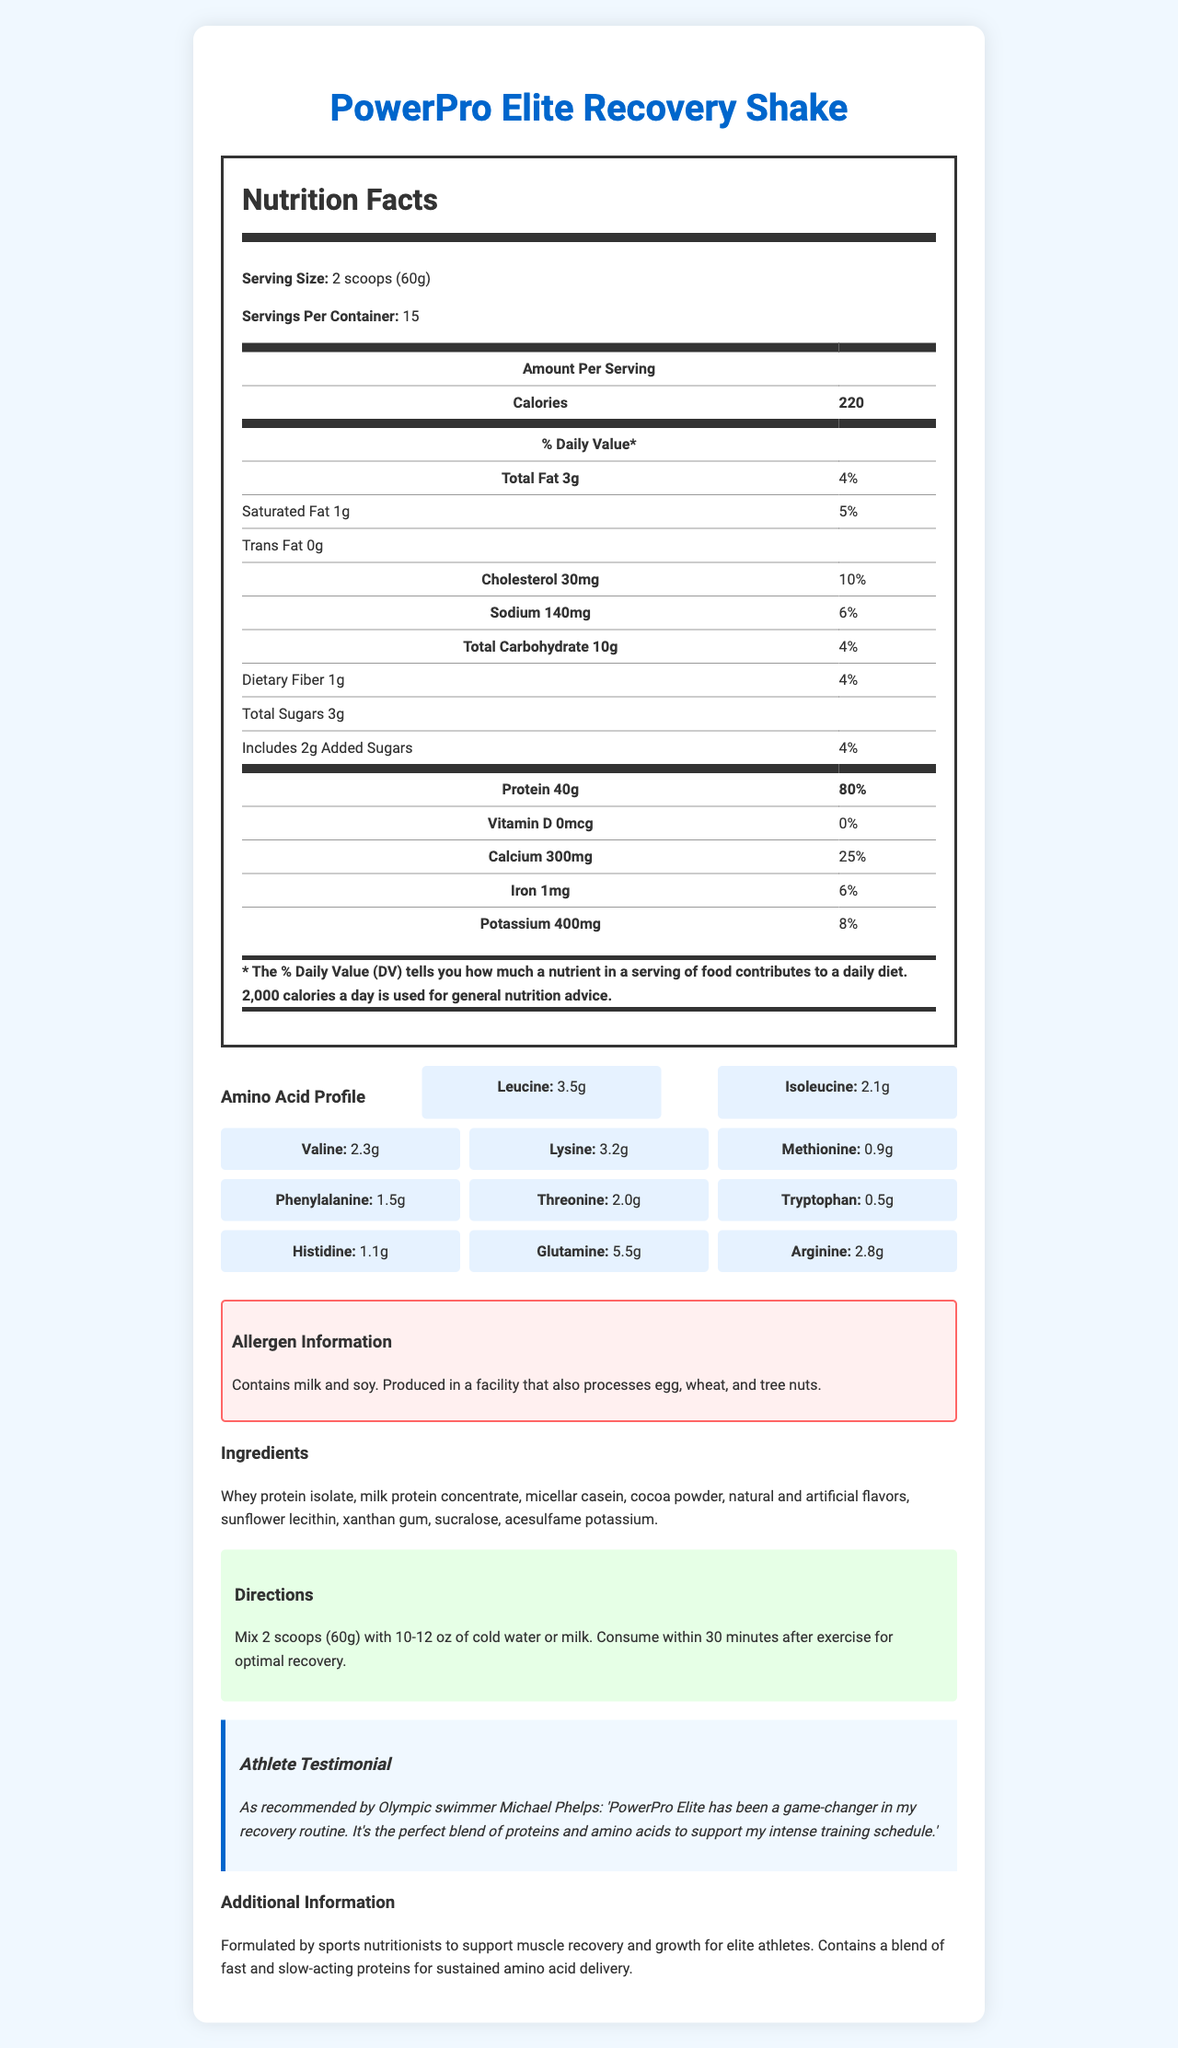What is the serving size of the PowerPro Elite Recovery Shake? The serving size is clearly stated in the "Nutrition Facts" section of the document.
Answer: 2 scoops (60g) How many servings are there per container? The document mentions "Servings Per Container: 15" in the "Nutrition Facts" section.
Answer: 15 How many grams of protein are in one serving of this recovery shake? The amount of protein per serving is specified as "40g" with a daily value percentage of "80%" in the "Nutrition Facts" section.
Answer: 40g What percentage of the Daily Value of calcium does one serving provide? The calcium content provides "25%" of the Daily Value, as per the "Nutrition Facts" section.
Answer: 25% Which amino acid has the highest content in the amino acid profile? The "Amino Acid Profile" section lists glutamine at "5.5g".
Answer: Glutamine Which of the following ingredients is NOT in the PowerPro Elite Recovery Shake? A. Whey protein isolate B. Soy protein isolate C. Cocoa powder D. Sucralose The ingredient list does not mention soy protein isolate but includes whey protein isolate, cocoa powder, and sucralose.
Answer: B. Soy protein isolate What is the total amount of fat per serving? The "Nutrition Facts" section lists "Total Fat 3g" with 4% of the Daily Value.
Answer: 3g Is there any dietary fiber in the shake? The shake contains "1g" of dietary fiber, which is "4%" of the Daily Value, according to the "Nutrition Facts" section.
Answer: Yes Does this product contain any allergens? The allergen information section states that the product contains milk and soy and is produced in a facility that processes egg, wheat, and tree nuts.
Answer: Yes Summarize the nutritional value and additional information provided in the document about the PowerPro Elite Recovery Shake. The explanation provides a detailed description of the nutritional value, amino acids, ingredients, and additional testimonials and information about the product.
Answer: The PowerPro Elite Recovery Shake has a serving size of 2 scoops (60g) with 15 servings per container. Each serving provides 220 calories, 3g of total fat, 30mg of cholesterol, 140mg of sodium, 10g of carbohydrates, 1g of dietary fiber, 3g of total sugars, and 40g of protein. It also contains significant amounts of calcium (25% DV) and potassium (8% DV). The product includes an amino acid profile with high levels of glutamine (5.5g) and other essential amino acids. Ingredients include whey protein isolate, milk protein concentrate, and micellar casein, among others. The product is noted for supporting muscle recovery and growth, is recommended by Olympic swimmer Michael Phelps, and has allergen warnings for milk and soy. What is the recommended consumption method for the PowerPro Elite Recovery Shake? This information is located in the "Directions" section of the document.
Answer: Mix 2 scoops (60g) with 10-12 oz of cold water or milk and consume within 30 minutes after exercise for optimal recovery. Which nutrient provides the highest percentage of the Daily Value in one serving? The "Nutrition Facts" section shows that protein provides "80%" of the Daily Value, which is the highest percentage listed.
Answer: Protein Who is the athlete endorsing this product? The document includes a testimonial from Olympic swimmer Michael Phelps, who endorses the product.
Answer: Michael Phelps Can you determine how this product affects calorie intake during a day from this document? While the document provides the number of calories per serving (220), it does not give information on how it fits into a daily meal plan, nor does it account for different individual caloric needs.
Answer: Not enough information What sweeteners are used in the PowerPro Elite Recovery Shake? These ingredients are listed toward the end of the ingredient list.
Answer: Sucralose and acesulfame potassium 